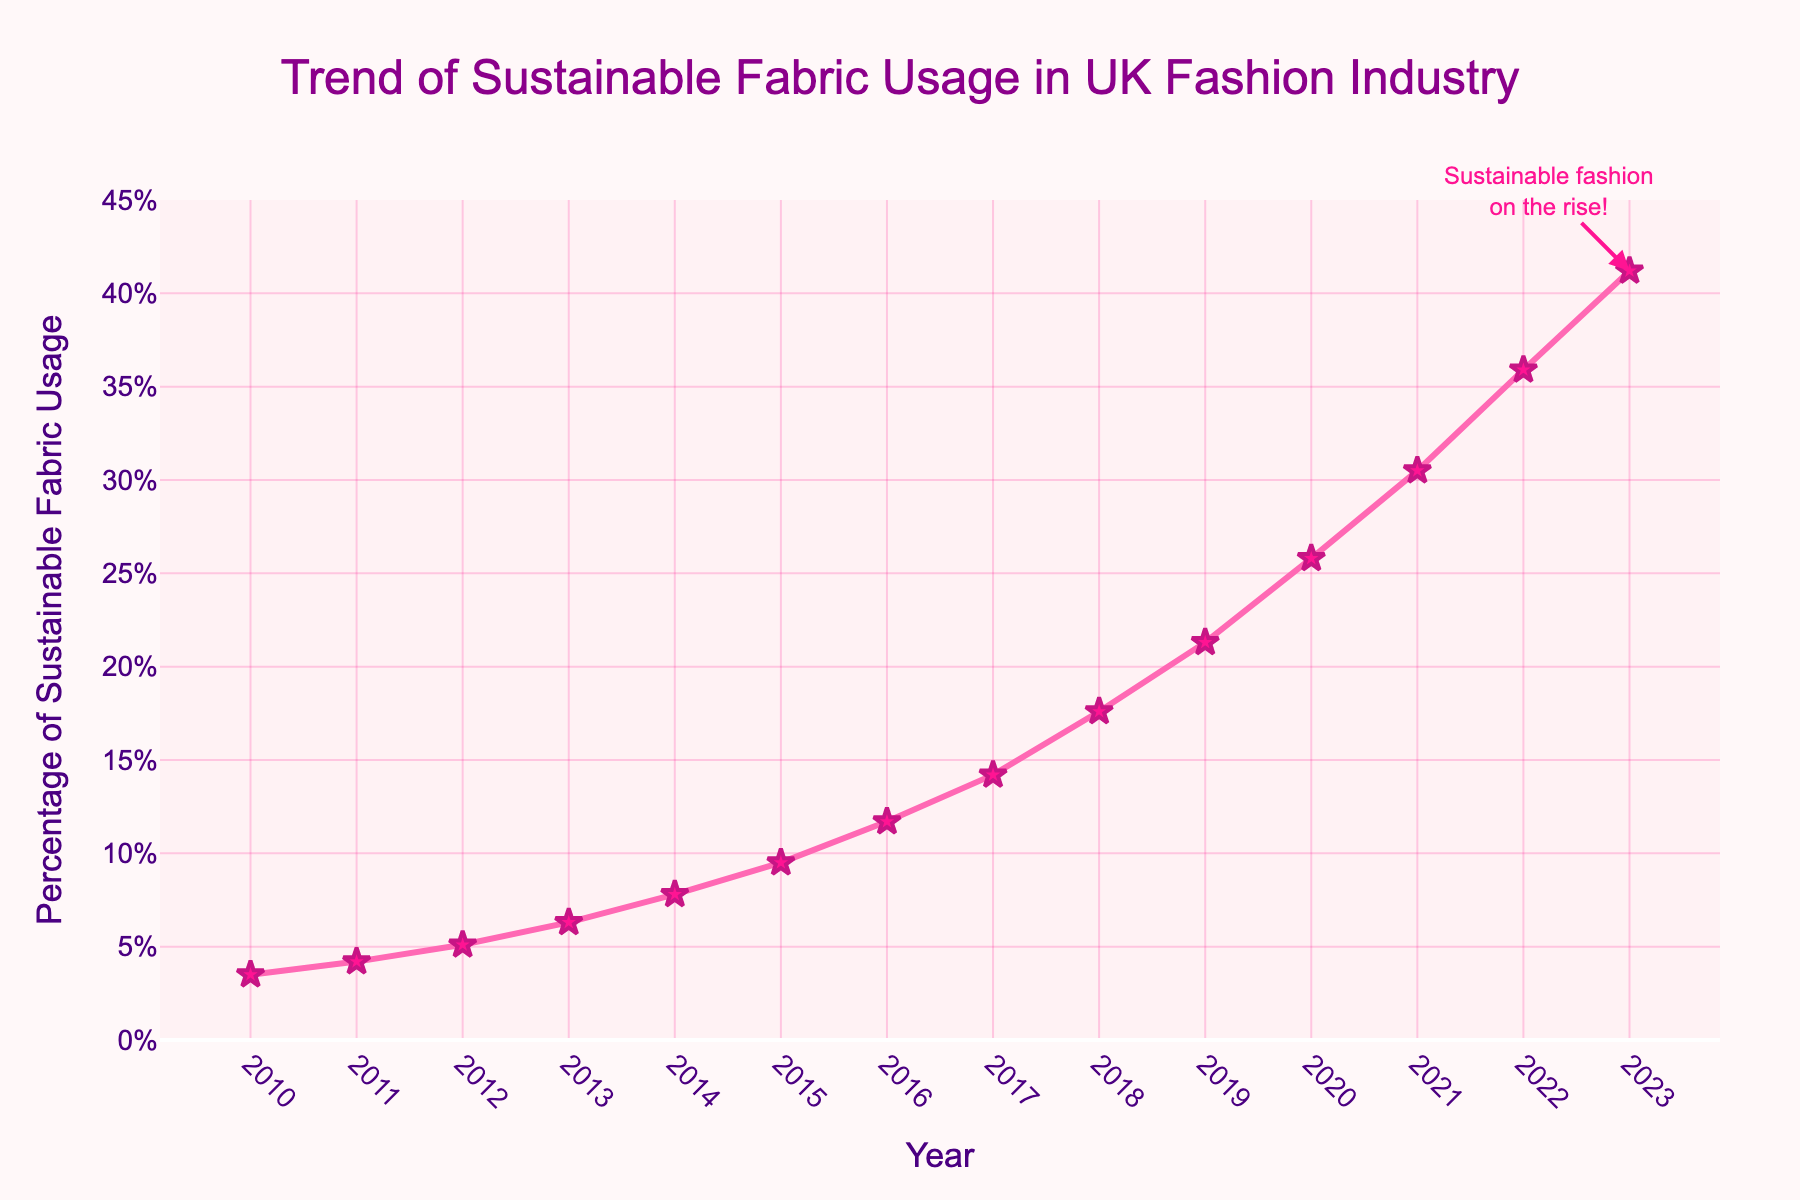What's the percentage of sustainable fabric usage in 2023? The percentage of sustainable fabric usage in 2023 can be directly read from the end of the line chart. The point for the year 2023 shows the value.
Answer: 41.2% How much did the percentage of sustainable fabric usage increase from 2010 to 2023? To find the increase, we subtract the 2010 percentage from the 2023 percentage. This is 41.2% (2023) - 3.5% (2010).
Answer: 37.7% Which year saw a higher percentage of sustainable fabric usage: 2015 or 2017? By locating the data points for the years 2015 and 2017 on the chart, the values can be compared. 2015 shows 9.5% and 2017 shows 14.2%.
Answer: 2017 What is the average percentage of sustainable fabric usage between 2010 and 2023? Sum up the percentages for each year and divide by the number of years. The sum is (3.5 + 4.2 + 5.1 + 6.3 + 7.8 + 9.5 + 11.7 + 14.2 + 17.6 + 21.3 + 25.8 + 30.5 + 35.9 + 41.2 = 234.6), divide by 14 (years): 234.6/14.
Answer: 16.76% What is the difference in sustainable fabric usage between the highest and lowest years? The highest value is in 2023 (41.2%) and the lowest is in 2010 (3.5%). Subtract the lowest from the highest: 41.2% - 3.5%.
Answer: 37.7% In which year did the sustainable fabric usage percentage first exceed 10%? Look at the percentage values on the line chart and find the year where the usage first goes above 10%. This is 2016 with 11.7%.
Answer: 2016 What was the percentage growth in sustainable fabric usage from 2019 to 2022? Subtract the 2019 value from the 2022 value to find the increase, and then divide by the 2019 value, finally multiply by 100 for the percentage growth: ((35.9 - 21.3) / 21.3) * 100.
Answer: 68.5% Compare the increase in sustainable fabric usage between 2011-2012 and 2020-2021. Which period saw a larger increase? Calculate the increase for each period by subtracting the earlier year's value from the later year's value: 
2011-2012: 5.1% - 4.2% = 0.9% 
2020-2021: 30.5% - 25.8% = 4.7%
4.7% > 0.9%, so 2020-2021 saw a larger increase.
Answer: 2020-2021 By looking at the annotated message on the chart, how is the sustainable fashion trend described? The annotation states "Sustainable fashion on the rise!" indicating an increasing trend.
Answer: On the rise 